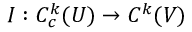Convert formula to latex. <formula><loc_0><loc_0><loc_500><loc_500>I \colon C _ { c } ^ { k } ( U ) \to C ^ { k } ( V )</formula> 